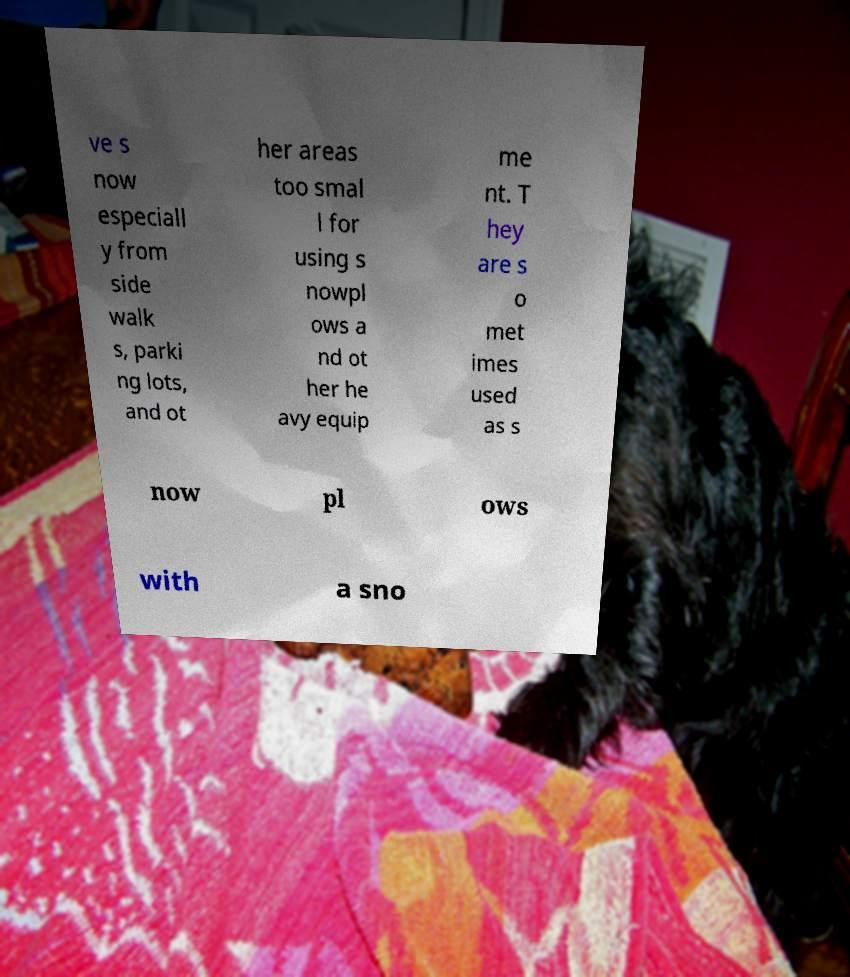Can you read and provide the text displayed in the image?This photo seems to have some interesting text. Can you extract and type it out for me? ve s now especiall y from side walk s, parki ng lots, and ot her areas too smal l for using s nowpl ows a nd ot her he avy equip me nt. T hey are s o met imes used as s now pl ows with a sno 